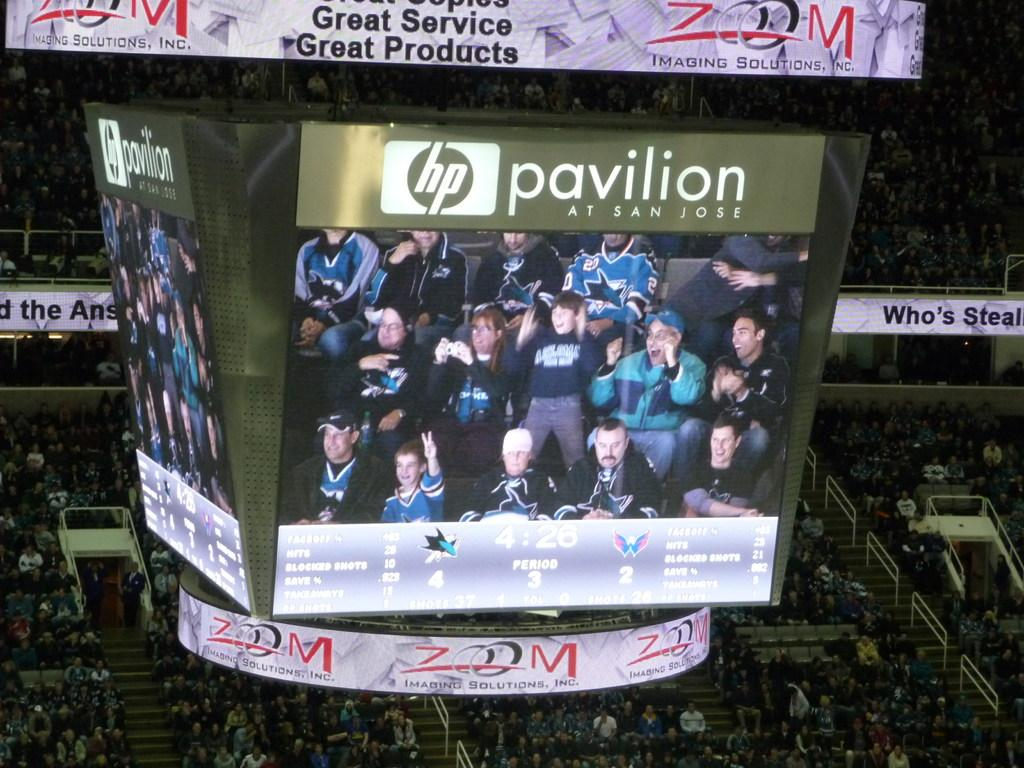<image>
Offer a succinct explanation of the picture presented. the word pavilion is next to an hp logo 